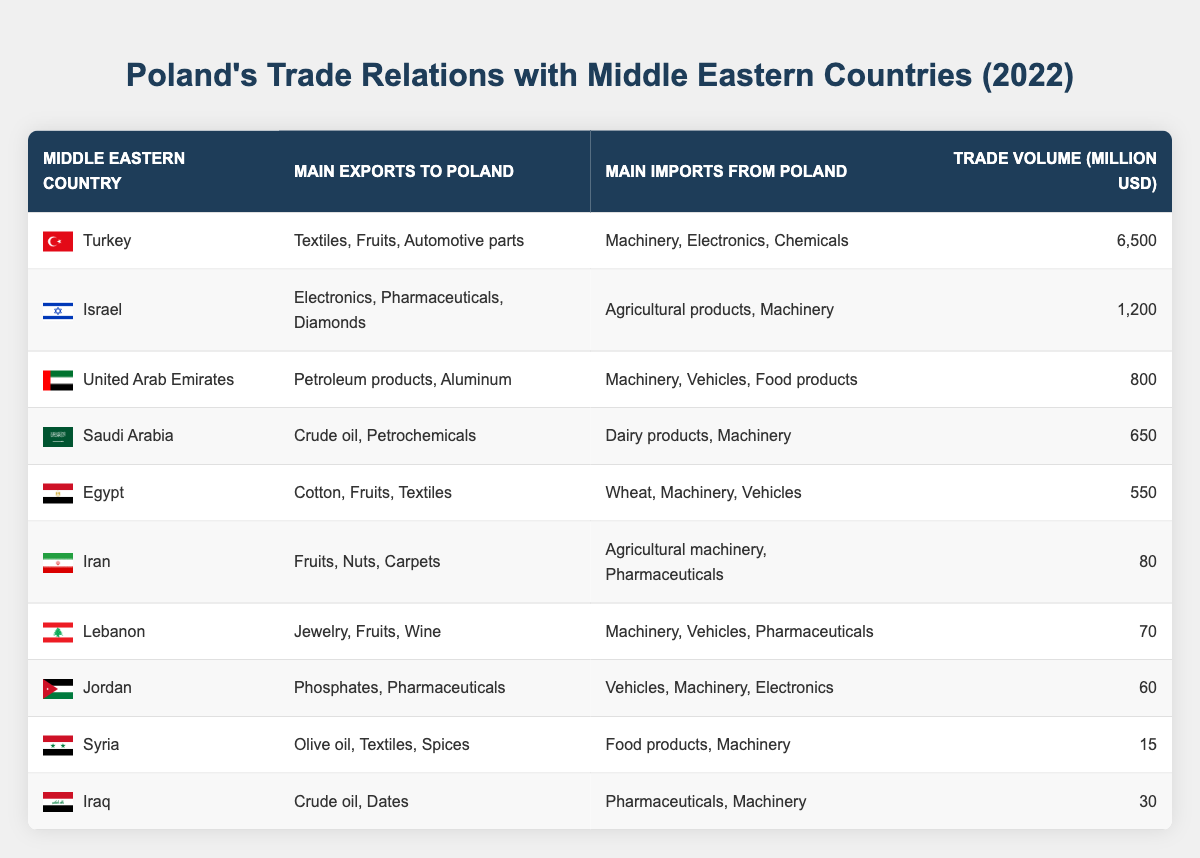What are the main exports from Turkey to Poland? From the table, under the "Main Exports to Poland" column, Turkey's exports include "Textiles, Fruits, Automotive parts."
Answer: Textiles, Fruits, Automotive parts Which Middle Eastern country has the highest trade volume with Poland? By comparing the values in the "Trade Volume (million USD)" column, Turkey has the highest trade volume at 6,500 million USD.
Answer: Turkey Is Poland's main import from Saudi Arabia dairy products? Checking the "Main Imports from Poland" row for Saudi Arabia, it states "Dairy products, Machinery." Therefore, yes, one of the main imports is dairy products.
Answer: Yes What is the total trade volume between Poland and Egypt, Syria, and Iraq? The individual trade volumes are: Egypt 550 million USD, Syria 15 million USD, and Iraq 30 million USD. Adding these together gives 550 + 15 + 30 = 595 million USD.
Answer: 595 million USD Does Iran primarily export crude oil to Poland? Looking at Iran's row in the "Main Exports to Poland" column, it states "Fruits, Nuts, Carpets," which confirms that crude oil is not one of its main exports.
Answer: No What are the total exports from Middle Eastern countries listed? To find the total exports, we can sum the exports listed in the table:  Toasting the values, we have: Turkey (Textiles, Fruits, Automotive parts), Israel (Electronics, Pharmaceuticals, Diamonds), UAE (Petroleum products, Aluminum), Saudi Arabia (Crude oil, Petrochemicals), Egypt (Cotton, Fruits, Textiles), Iran (Fruits, Nuts, Carpets), Lebanon (Jewelry, Fruits, Wine), Jordan (Phosphates, Pharmaceuticals), Syria (Olive oil, Textiles, Spices), and Iraq (Crude oil, Dates). We sum the number of countries which is 10.
Answer: 10 Are there any Middle Eastern countries that export both textiles and machinery to Poland? Looking through the table, Turkey exports textiles and imports machinery, while Egypt exports textiles and imports machinery, confirming that both exist in the dataset.
Answer: Yes 